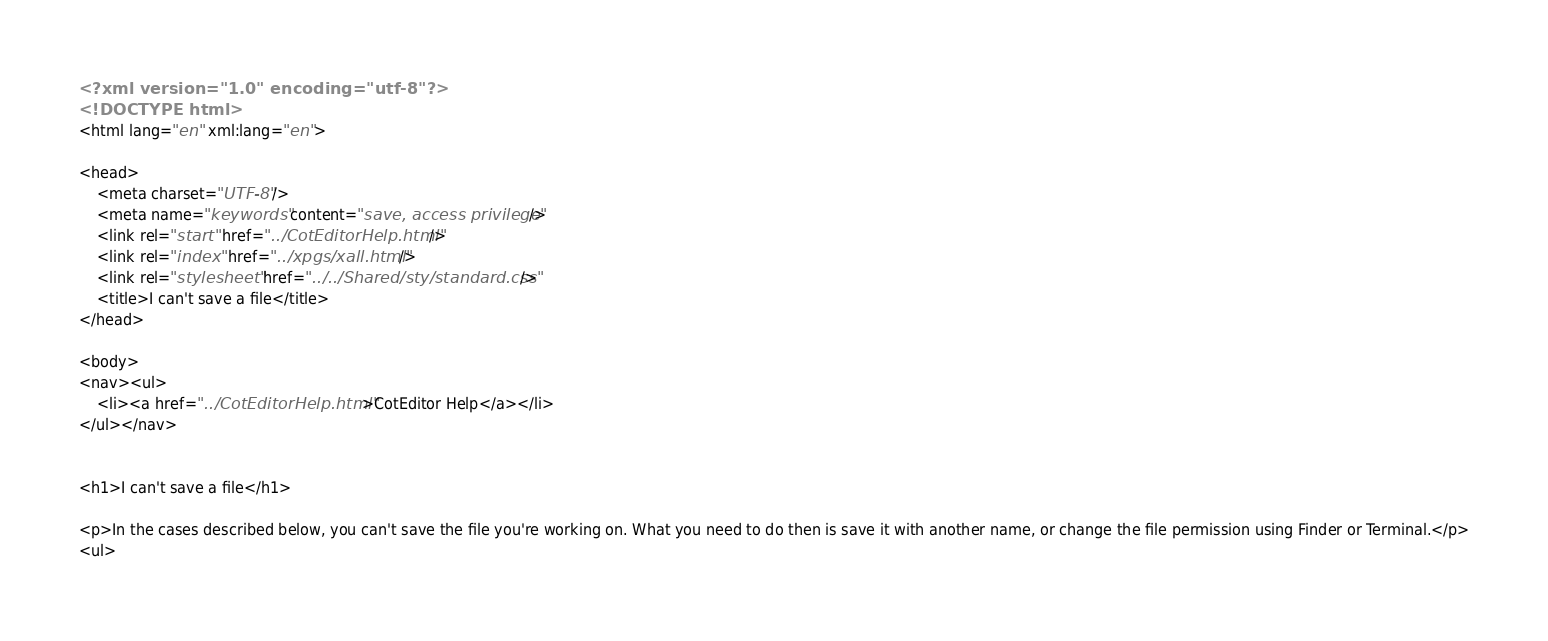Convert code to text. <code><loc_0><loc_0><loc_500><loc_500><_HTML_><?xml version="1.0" encoding="utf-8"?>
<!DOCTYPE html>
<html lang="en" xml:lang="en">

<head>
	<meta charset="UTF-8"/>
	<meta name="keywords" content="save, access privilege"/>
	<link rel="start" href="../CotEditorHelp.html"/>
	<link rel="index" href="../xpgs/xall.html"/>
	<link rel="stylesheet" href="../../Shared/sty/standard.css"/>
	<title>I can't save a file</title>
</head>

<body>
<nav><ul>
	<li><a href="../CotEditorHelp.html">CotEditor Help</a></li>
</ul></nav>


<h1>I can't save a file</h1>

<p>In the cases described below, you can't save the file you're working on. What you need to do then is save it with another name, or change the file permission using Finder or Terminal.</p>
<ul></code> 